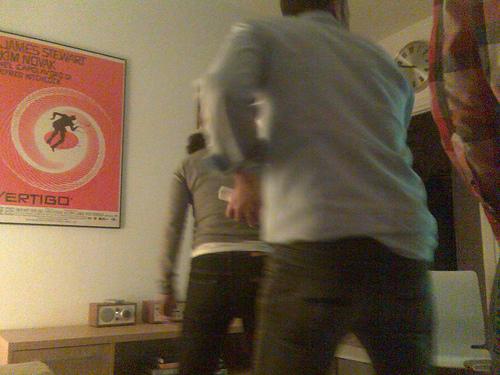What time is shown on the clock?
Keep it brief. 9:50. What color is the man in the poster?
Short answer required. Black. What color is the shit on the left?
Write a very short answer. Gray. Is there an actual person in this picture?
Write a very short answer. Yes. What word is written from top to bottom on the right edge of the poster?
Give a very brief answer. Vertigo. Why is this image blurry?
Keep it brief. Moving. Is the person sitting or standing?
Be succinct. Standing. 